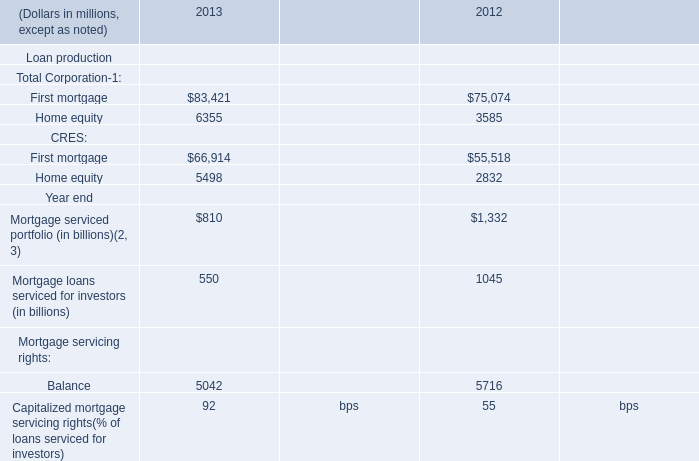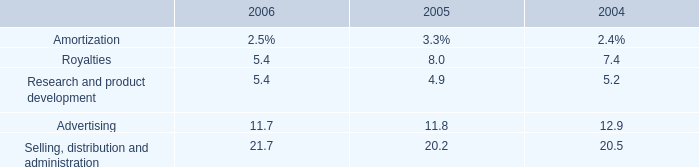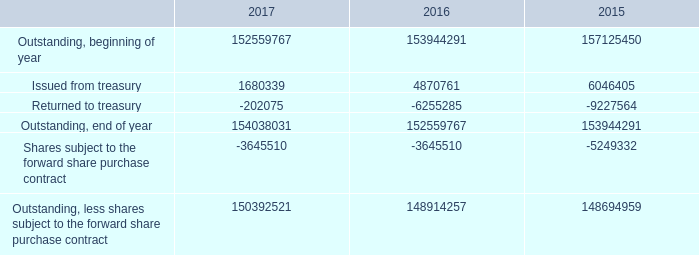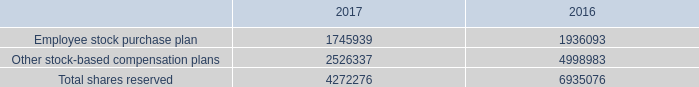What's the total amount of Home equity in 2013 and 2012? (in million) 
Computations: (6355 + 3585)
Answer: 9940.0. 